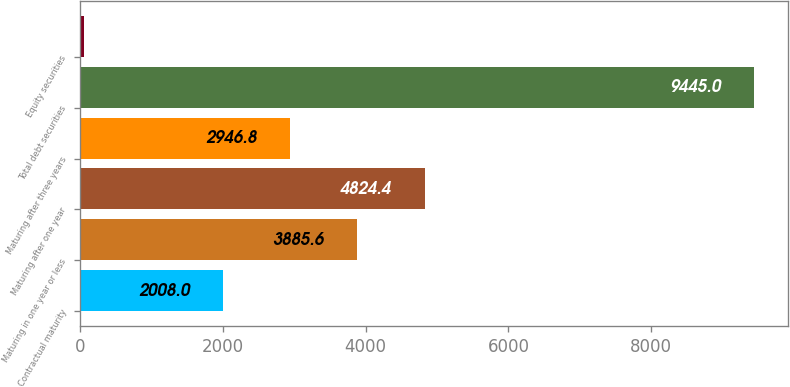Convert chart. <chart><loc_0><loc_0><loc_500><loc_500><bar_chart><fcel>Contractual maturity<fcel>Maturing in one year or less<fcel>Maturing after one year<fcel>Maturing after three years<fcel>Total debt securities<fcel>Equity securities<nl><fcel>2008<fcel>3885.6<fcel>4824.4<fcel>2946.8<fcel>9445<fcel>57<nl></chart> 